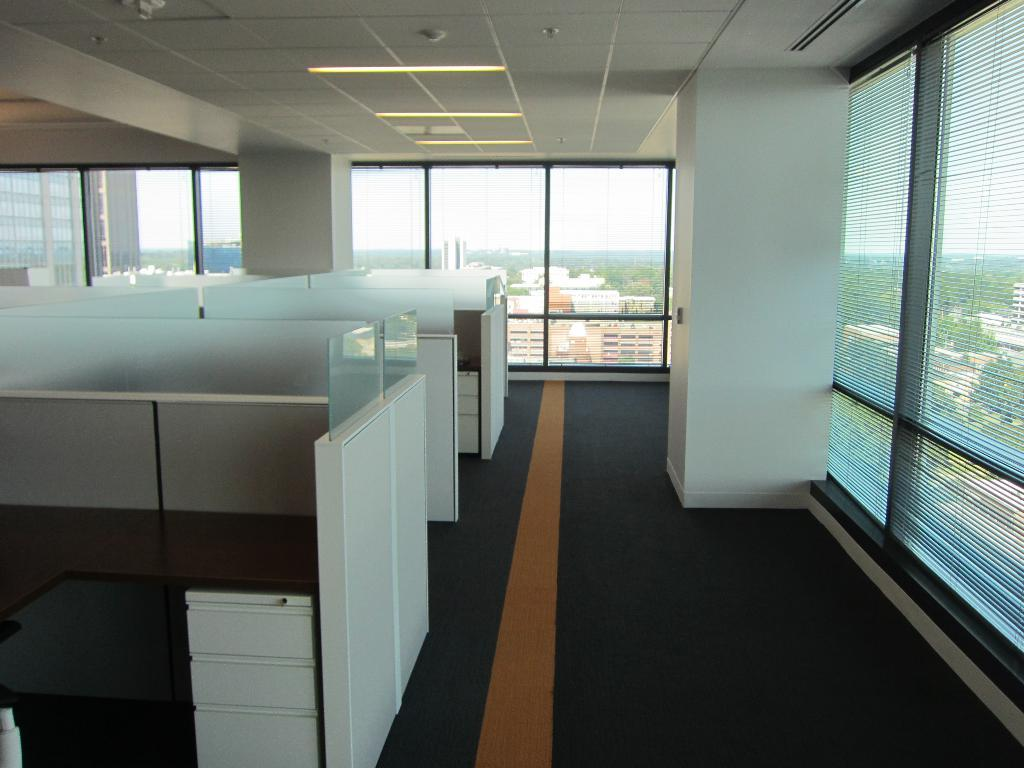What type of space is shown in the image? The image depicts an interior part of an office room. What can be seen on the left side of the image? There are work desks in the left side of the image. What is the color of the work desks? The work desks are white in color. What is present on the right side of the image? There is a glass wall in the right side of the image. How many frogs are sitting on the work desks in the image? There are no frogs present in the image; it depicts an office room with work desks and a glass wall. 